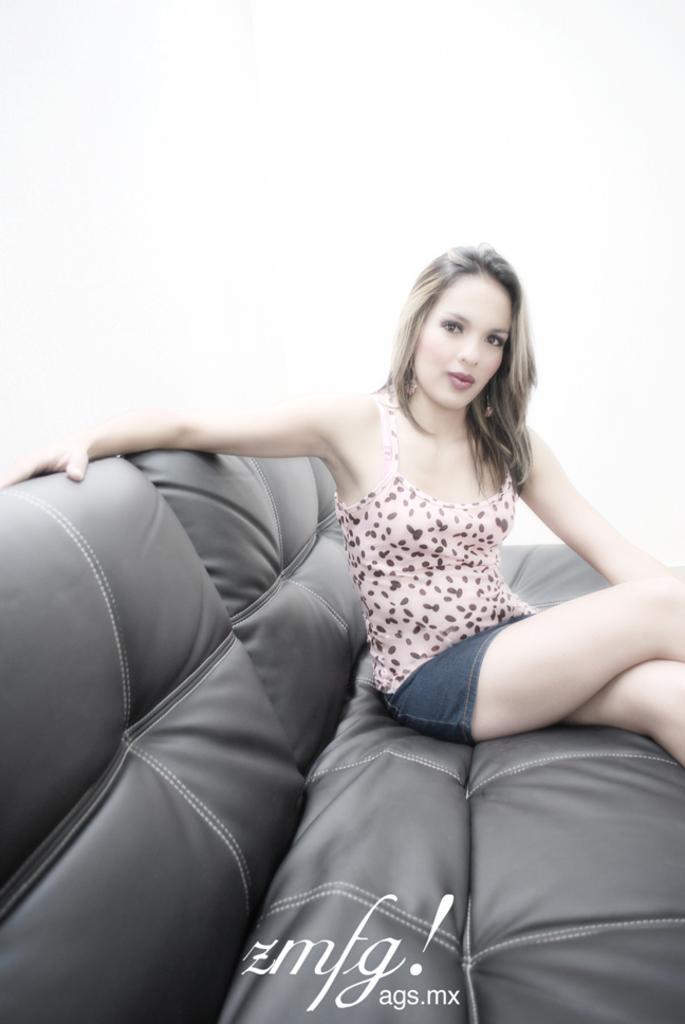Could you give a brief overview of what you see in this image? In the foreground of this image, there is a woman sitting on a couch and the background image is white. 